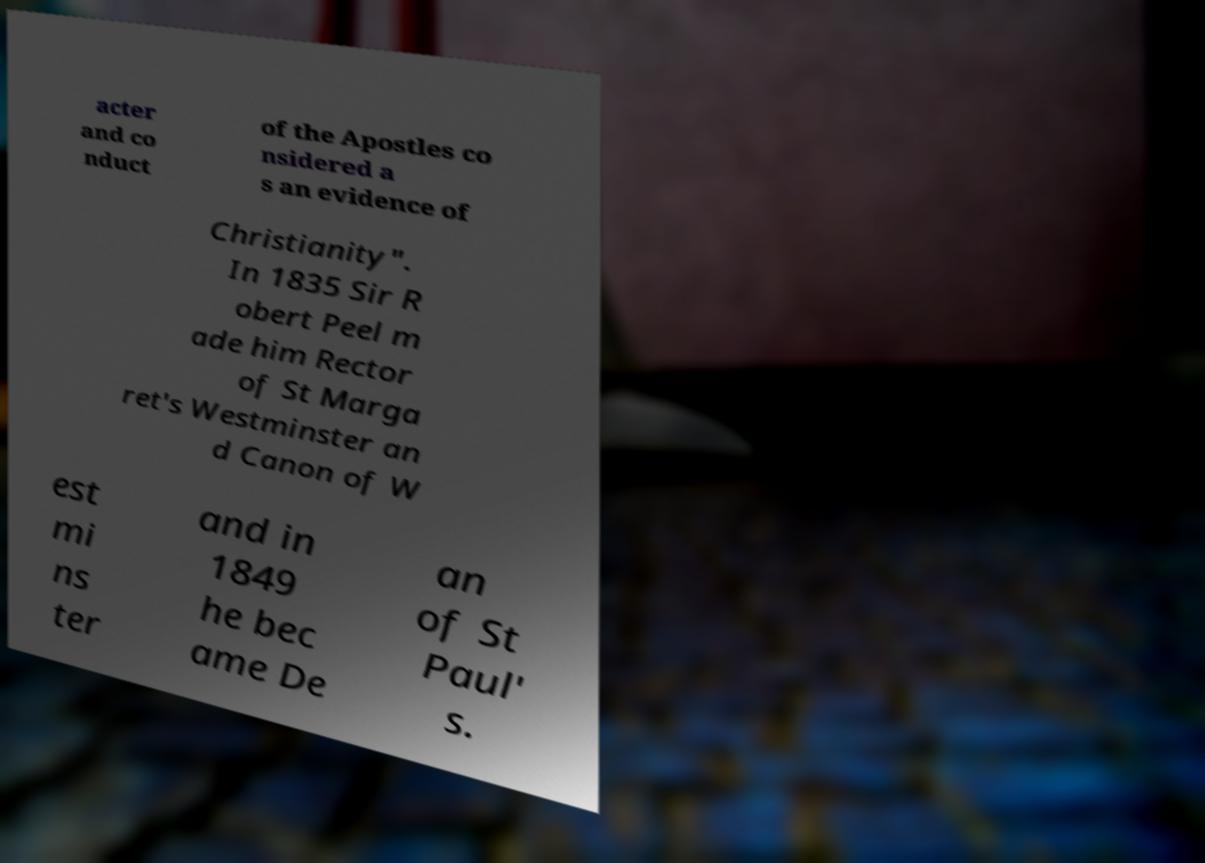Please read and relay the text visible in this image. What does it say? acter and co nduct of the Apostles co nsidered a s an evidence of Christianity". In 1835 Sir R obert Peel m ade him Rector of St Marga ret's Westminster an d Canon of W est mi ns ter and in 1849 he bec ame De an of St Paul' s. 